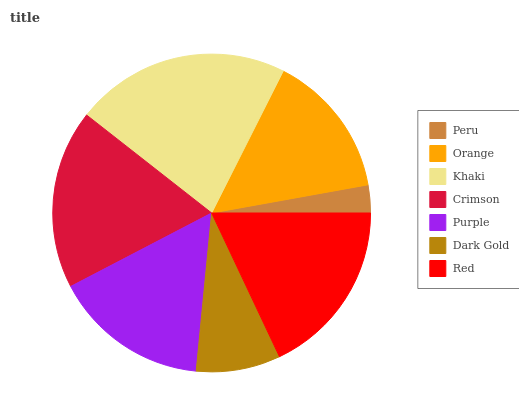Is Peru the minimum?
Answer yes or no. Yes. Is Khaki the maximum?
Answer yes or no. Yes. Is Orange the minimum?
Answer yes or no. No. Is Orange the maximum?
Answer yes or no. No. Is Orange greater than Peru?
Answer yes or no. Yes. Is Peru less than Orange?
Answer yes or no. Yes. Is Peru greater than Orange?
Answer yes or no. No. Is Orange less than Peru?
Answer yes or no. No. Is Purple the high median?
Answer yes or no. Yes. Is Purple the low median?
Answer yes or no. Yes. Is Crimson the high median?
Answer yes or no. No. Is Red the low median?
Answer yes or no. No. 